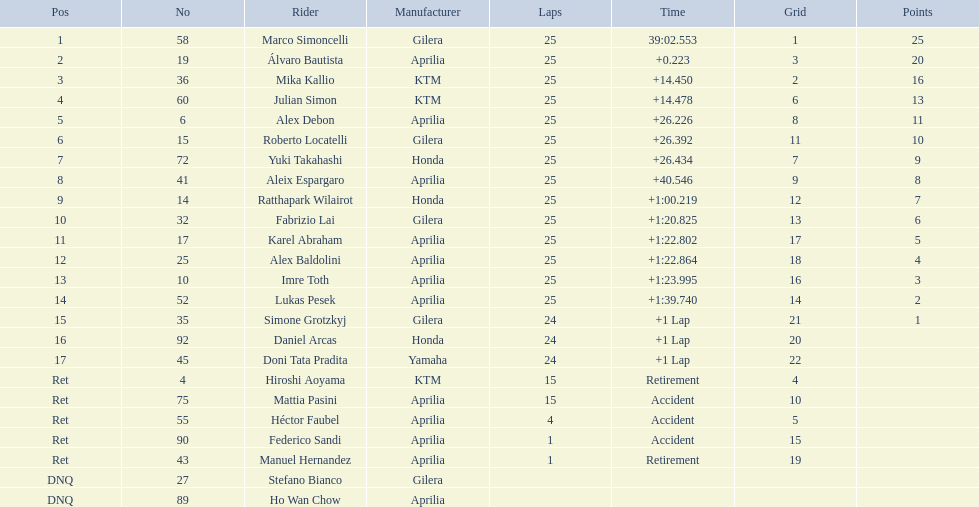What was the fastest overall time? 39:02.553. Parse the full table in json format. {'header': ['Pos', 'No', 'Rider', 'Manufacturer', 'Laps', 'Time', 'Grid', 'Points'], 'rows': [['1', '58', 'Marco Simoncelli', 'Gilera', '25', '39:02.553', '1', '25'], ['2', '19', 'Álvaro Bautista', 'Aprilia', '25', '+0.223', '3', '20'], ['3', '36', 'Mika Kallio', 'KTM', '25', '+14.450', '2', '16'], ['4', '60', 'Julian Simon', 'KTM', '25', '+14.478', '6', '13'], ['5', '6', 'Alex Debon', 'Aprilia', '25', '+26.226', '8', '11'], ['6', '15', 'Roberto Locatelli', 'Gilera', '25', '+26.392', '11', '10'], ['7', '72', 'Yuki Takahashi', 'Honda', '25', '+26.434', '7', '9'], ['8', '41', 'Aleix Espargaro', 'Aprilia', '25', '+40.546', '9', '8'], ['9', '14', 'Ratthapark Wilairot', 'Honda', '25', '+1:00.219', '12', '7'], ['10', '32', 'Fabrizio Lai', 'Gilera', '25', '+1:20.825', '13', '6'], ['11', '17', 'Karel Abraham', 'Aprilia', '25', '+1:22.802', '17', '5'], ['12', '25', 'Alex Baldolini', 'Aprilia', '25', '+1:22.864', '18', '4'], ['13', '10', 'Imre Toth', 'Aprilia', '25', '+1:23.995', '16', '3'], ['14', '52', 'Lukas Pesek', 'Aprilia', '25', '+1:39.740', '14', '2'], ['15', '35', 'Simone Grotzkyj', 'Gilera', '24', '+1 Lap', '21', '1'], ['16', '92', 'Daniel Arcas', 'Honda', '24', '+1 Lap', '20', ''], ['17', '45', 'Doni Tata Pradita', 'Yamaha', '24', '+1 Lap', '22', ''], ['Ret', '4', 'Hiroshi Aoyama', 'KTM', '15', 'Retirement', '4', ''], ['Ret', '75', 'Mattia Pasini', 'Aprilia', '15', 'Accident', '10', ''], ['Ret', '55', 'Héctor Faubel', 'Aprilia', '4', 'Accident', '5', ''], ['Ret', '90', 'Federico Sandi', 'Aprilia', '1', 'Accident', '15', ''], ['Ret', '43', 'Manuel Hernandez', 'Aprilia', '1', 'Retirement', '19', ''], ['DNQ', '27', 'Stefano Bianco', 'Gilera', '', '', '', ''], ['DNQ', '89', 'Ho Wan Chow', 'Aprilia', '', '', '', '']]} Who does this time belong to? Marco Simoncelli. 